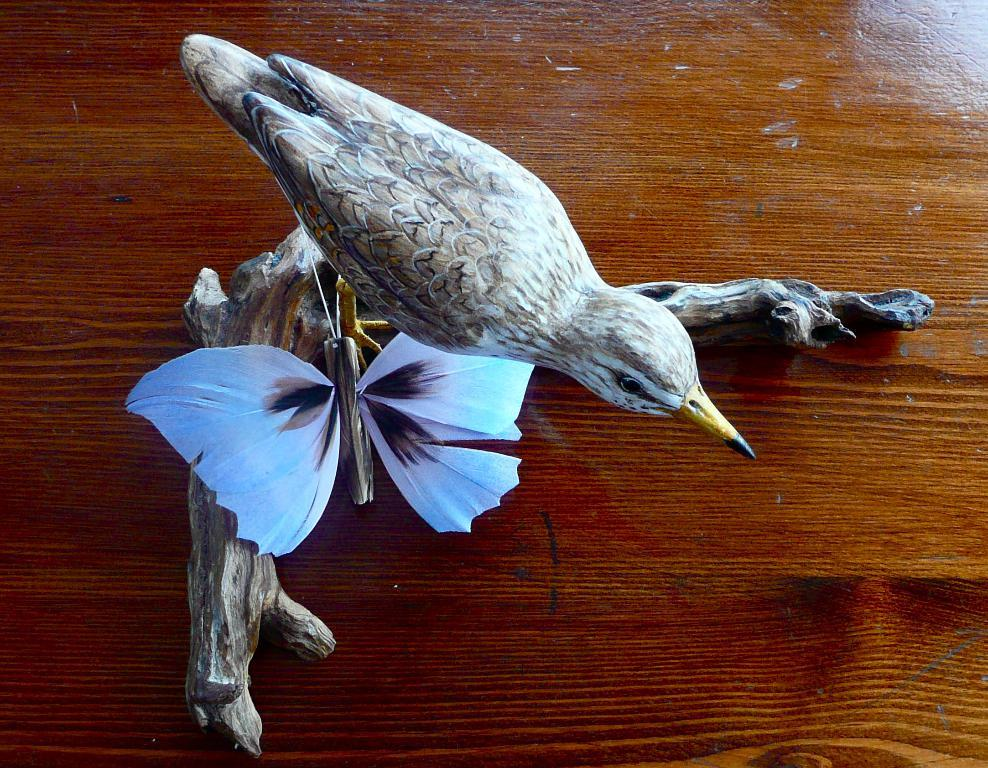What type of object can be seen in the image? There is a shoe in the image. What other living creature is present in the image? There is a butterfly in the image. What part of a bird is visible in the image? There is a piece of a bird in the image. What is the color of the surface on which the objects are placed? The objects are on a brown color surface. How far can the writer swim in the image? There is no writer or swimming activity present in the image. 